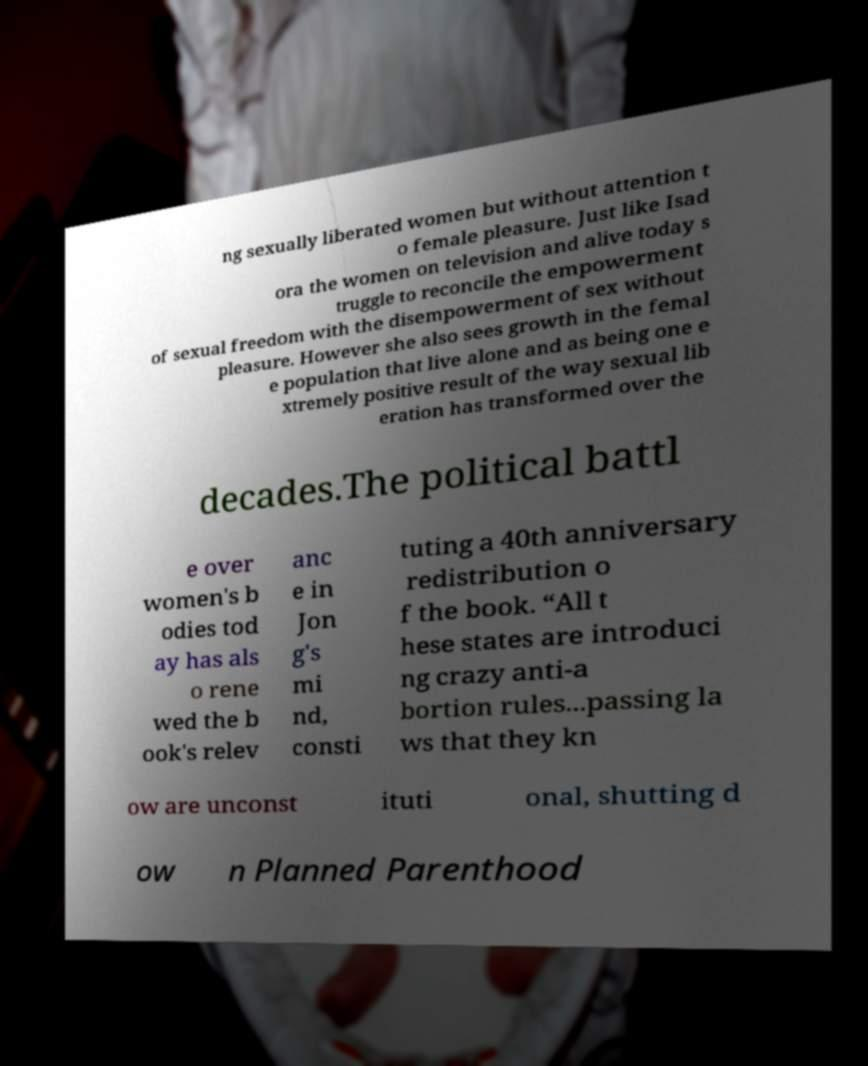Can you accurately transcribe the text from the provided image for me? ng sexually liberated women but without attention t o female pleasure. Just like Isad ora the women on television and alive today s truggle to reconcile the empowerment of sexual freedom with the disempowerment of sex without pleasure. However she also sees growth in the femal e population that live alone and as being one e xtremely positive result of the way sexual lib eration has transformed over the decades.The political battl e over women's b odies tod ay has als o rene wed the b ook's relev anc e in Jon g's mi nd, consti tuting a 40th anniversary redistribution o f the book. “All t hese states are introduci ng crazy anti-a bortion rules...passing la ws that they kn ow are unconst ituti onal, shutting d ow n Planned Parenthood 